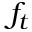Convert formula to latex. <formula><loc_0><loc_0><loc_500><loc_500>f _ { t }</formula> 